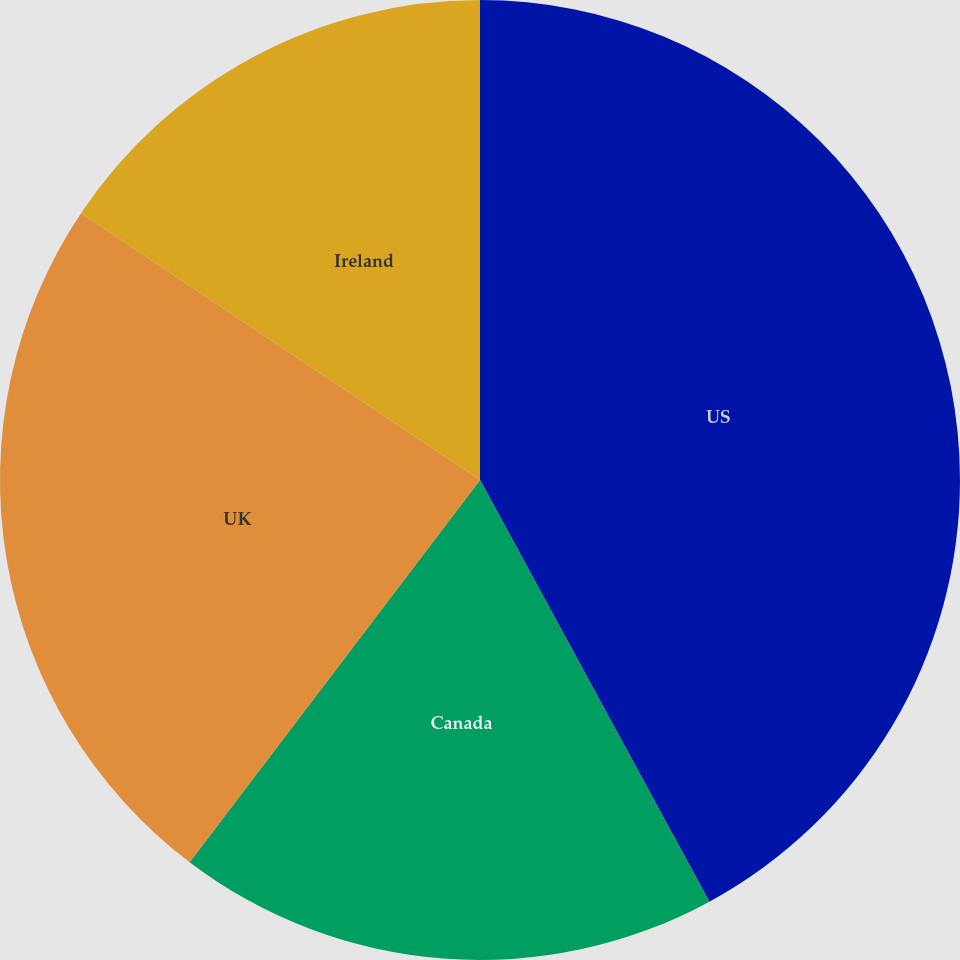Convert chart. <chart><loc_0><loc_0><loc_500><loc_500><pie_chart><fcel>US<fcel>Canada<fcel>UK<fcel>Ireland<nl><fcel>42.07%<fcel>18.27%<fcel>24.04%<fcel>15.62%<nl></chart> 